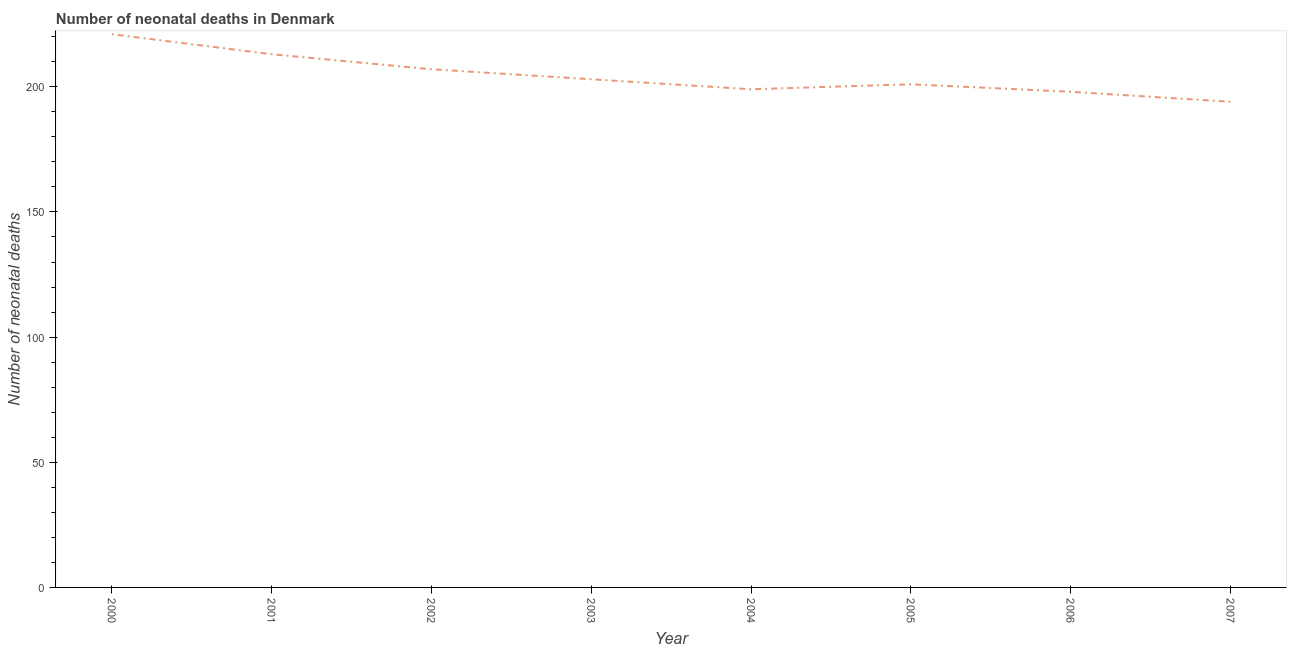What is the number of neonatal deaths in 2003?
Your response must be concise. 203. Across all years, what is the maximum number of neonatal deaths?
Make the answer very short. 221. Across all years, what is the minimum number of neonatal deaths?
Provide a succinct answer. 194. In which year was the number of neonatal deaths maximum?
Keep it short and to the point. 2000. In which year was the number of neonatal deaths minimum?
Make the answer very short. 2007. What is the sum of the number of neonatal deaths?
Your answer should be compact. 1636. What is the difference between the number of neonatal deaths in 2004 and 2005?
Ensure brevity in your answer.  -2. What is the average number of neonatal deaths per year?
Your answer should be compact. 204.5. What is the median number of neonatal deaths?
Provide a succinct answer. 202. What is the ratio of the number of neonatal deaths in 2002 to that in 2007?
Your answer should be very brief. 1.07. Is the number of neonatal deaths in 2003 less than that in 2005?
Ensure brevity in your answer.  No. Is the difference between the number of neonatal deaths in 2001 and 2005 greater than the difference between any two years?
Ensure brevity in your answer.  No. What is the difference between the highest and the second highest number of neonatal deaths?
Your answer should be compact. 8. What is the difference between the highest and the lowest number of neonatal deaths?
Your answer should be very brief. 27. How many lines are there?
Ensure brevity in your answer.  1. What is the difference between two consecutive major ticks on the Y-axis?
Offer a terse response. 50. Are the values on the major ticks of Y-axis written in scientific E-notation?
Keep it short and to the point. No. What is the title of the graph?
Keep it short and to the point. Number of neonatal deaths in Denmark. What is the label or title of the Y-axis?
Give a very brief answer. Number of neonatal deaths. What is the Number of neonatal deaths of 2000?
Ensure brevity in your answer.  221. What is the Number of neonatal deaths of 2001?
Your response must be concise. 213. What is the Number of neonatal deaths of 2002?
Make the answer very short. 207. What is the Number of neonatal deaths of 2003?
Provide a succinct answer. 203. What is the Number of neonatal deaths in 2004?
Provide a succinct answer. 199. What is the Number of neonatal deaths in 2005?
Give a very brief answer. 201. What is the Number of neonatal deaths of 2006?
Provide a succinct answer. 198. What is the Number of neonatal deaths of 2007?
Give a very brief answer. 194. What is the difference between the Number of neonatal deaths in 2000 and 2001?
Your answer should be compact. 8. What is the difference between the Number of neonatal deaths in 2000 and 2002?
Give a very brief answer. 14. What is the difference between the Number of neonatal deaths in 2000 and 2003?
Give a very brief answer. 18. What is the difference between the Number of neonatal deaths in 2000 and 2006?
Offer a very short reply. 23. What is the difference between the Number of neonatal deaths in 2001 and 2003?
Your answer should be very brief. 10. What is the difference between the Number of neonatal deaths in 2001 and 2004?
Provide a succinct answer. 14. What is the difference between the Number of neonatal deaths in 2001 and 2005?
Provide a succinct answer. 12. What is the difference between the Number of neonatal deaths in 2001 and 2007?
Ensure brevity in your answer.  19. What is the difference between the Number of neonatal deaths in 2002 and 2004?
Ensure brevity in your answer.  8. What is the difference between the Number of neonatal deaths in 2002 and 2005?
Make the answer very short. 6. What is the difference between the Number of neonatal deaths in 2002 and 2006?
Offer a very short reply. 9. What is the difference between the Number of neonatal deaths in 2002 and 2007?
Provide a short and direct response. 13. What is the difference between the Number of neonatal deaths in 2003 and 2004?
Make the answer very short. 4. What is the difference between the Number of neonatal deaths in 2003 and 2007?
Your answer should be compact. 9. What is the difference between the Number of neonatal deaths in 2004 and 2005?
Your response must be concise. -2. What is the difference between the Number of neonatal deaths in 2005 and 2006?
Ensure brevity in your answer.  3. What is the difference between the Number of neonatal deaths in 2005 and 2007?
Provide a succinct answer. 7. What is the difference between the Number of neonatal deaths in 2006 and 2007?
Provide a short and direct response. 4. What is the ratio of the Number of neonatal deaths in 2000 to that in 2001?
Your response must be concise. 1.04. What is the ratio of the Number of neonatal deaths in 2000 to that in 2002?
Provide a succinct answer. 1.07. What is the ratio of the Number of neonatal deaths in 2000 to that in 2003?
Give a very brief answer. 1.09. What is the ratio of the Number of neonatal deaths in 2000 to that in 2004?
Keep it short and to the point. 1.11. What is the ratio of the Number of neonatal deaths in 2000 to that in 2006?
Your answer should be compact. 1.12. What is the ratio of the Number of neonatal deaths in 2000 to that in 2007?
Ensure brevity in your answer.  1.14. What is the ratio of the Number of neonatal deaths in 2001 to that in 2003?
Keep it short and to the point. 1.05. What is the ratio of the Number of neonatal deaths in 2001 to that in 2004?
Give a very brief answer. 1.07. What is the ratio of the Number of neonatal deaths in 2001 to that in 2005?
Your answer should be very brief. 1.06. What is the ratio of the Number of neonatal deaths in 2001 to that in 2006?
Offer a terse response. 1.08. What is the ratio of the Number of neonatal deaths in 2001 to that in 2007?
Make the answer very short. 1.1. What is the ratio of the Number of neonatal deaths in 2002 to that in 2004?
Ensure brevity in your answer.  1.04. What is the ratio of the Number of neonatal deaths in 2002 to that in 2006?
Your response must be concise. 1.04. What is the ratio of the Number of neonatal deaths in 2002 to that in 2007?
Provide a short and direct response. 1.07. What is the ratio of the Number of neonatal deaths in 2003 to that in 2005?
Your answer should be compact. 1.01. What is the ratio of the Number of neonatal deaths in 2003 to that in 2006?
Ensure brevity in your answer.  1.02. What is the ratio of the Number of neonatal deaths in 2003 to that in 2007?
Your answer should be very brief. 1.05. What is the ratio of the Number of neonatal deaths in 2005 to that in 2006?
Ensure brevity in your answer.  1.01. What is the ratio of the Number of neonatal deaths in 2005 to that in 2007?
Provide a short and direct response. 1.04. What is the ratio of the Number of neonatal deaths in 2006 to that in 2007?
Offer a terse response. 1.02. 